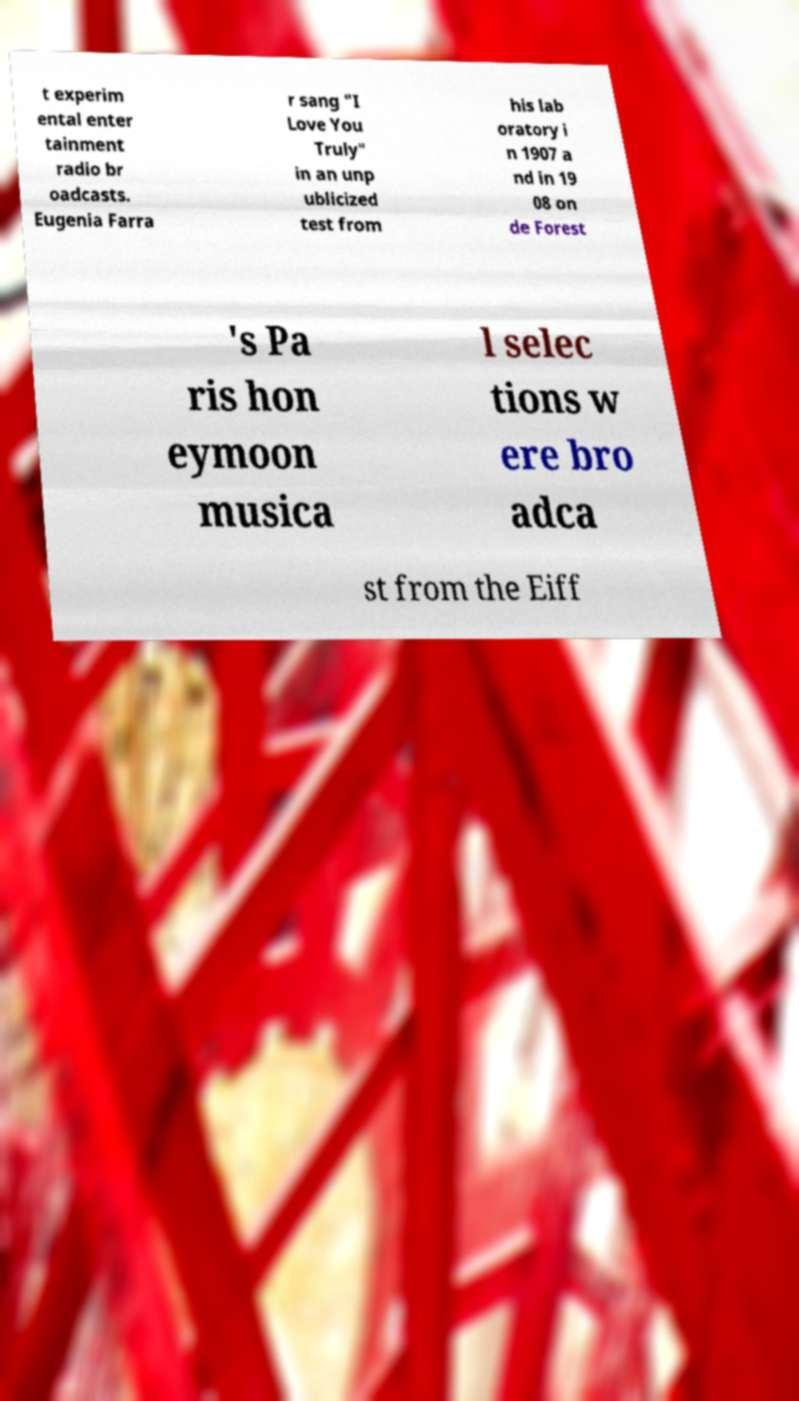Could you extract and type out the text from this image? t experim ental enter tainment radio br oadcasts. Eugenia Farra r sang "I Love You Truly" in an unp ublicized test from his lab oratory i n 1907 a nd in 19 08 on de Forest 's Pa ris hon eymoon musica l selec tions w ere bro adca st from the Eiff 